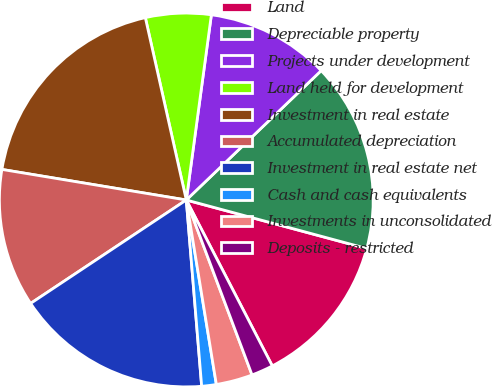Convert chart. <chart><loc_0><loc_0><loc_500><loc_500><pie_chart><fcel>Land<fcel>Depreciable property<fcel>Projects under development<fcel>Land held for development<fcel>Investment in real estate<fcel>Accumulated depreciation<fcel>Investment in real estate net<fcel>Cash and cash equivalents<fcel>Investments in unconsolidated<fcel>Deposits - restricted<nl><fcel>13.21%<fcel>16.35%<fcel>10.69%<fcel>5.66%<fcel>18.87%<fcel>11.95%<fcel>16.98%<fcel>1.26%<fcel>3.15%<fcel>1.89%<nl></chart> 